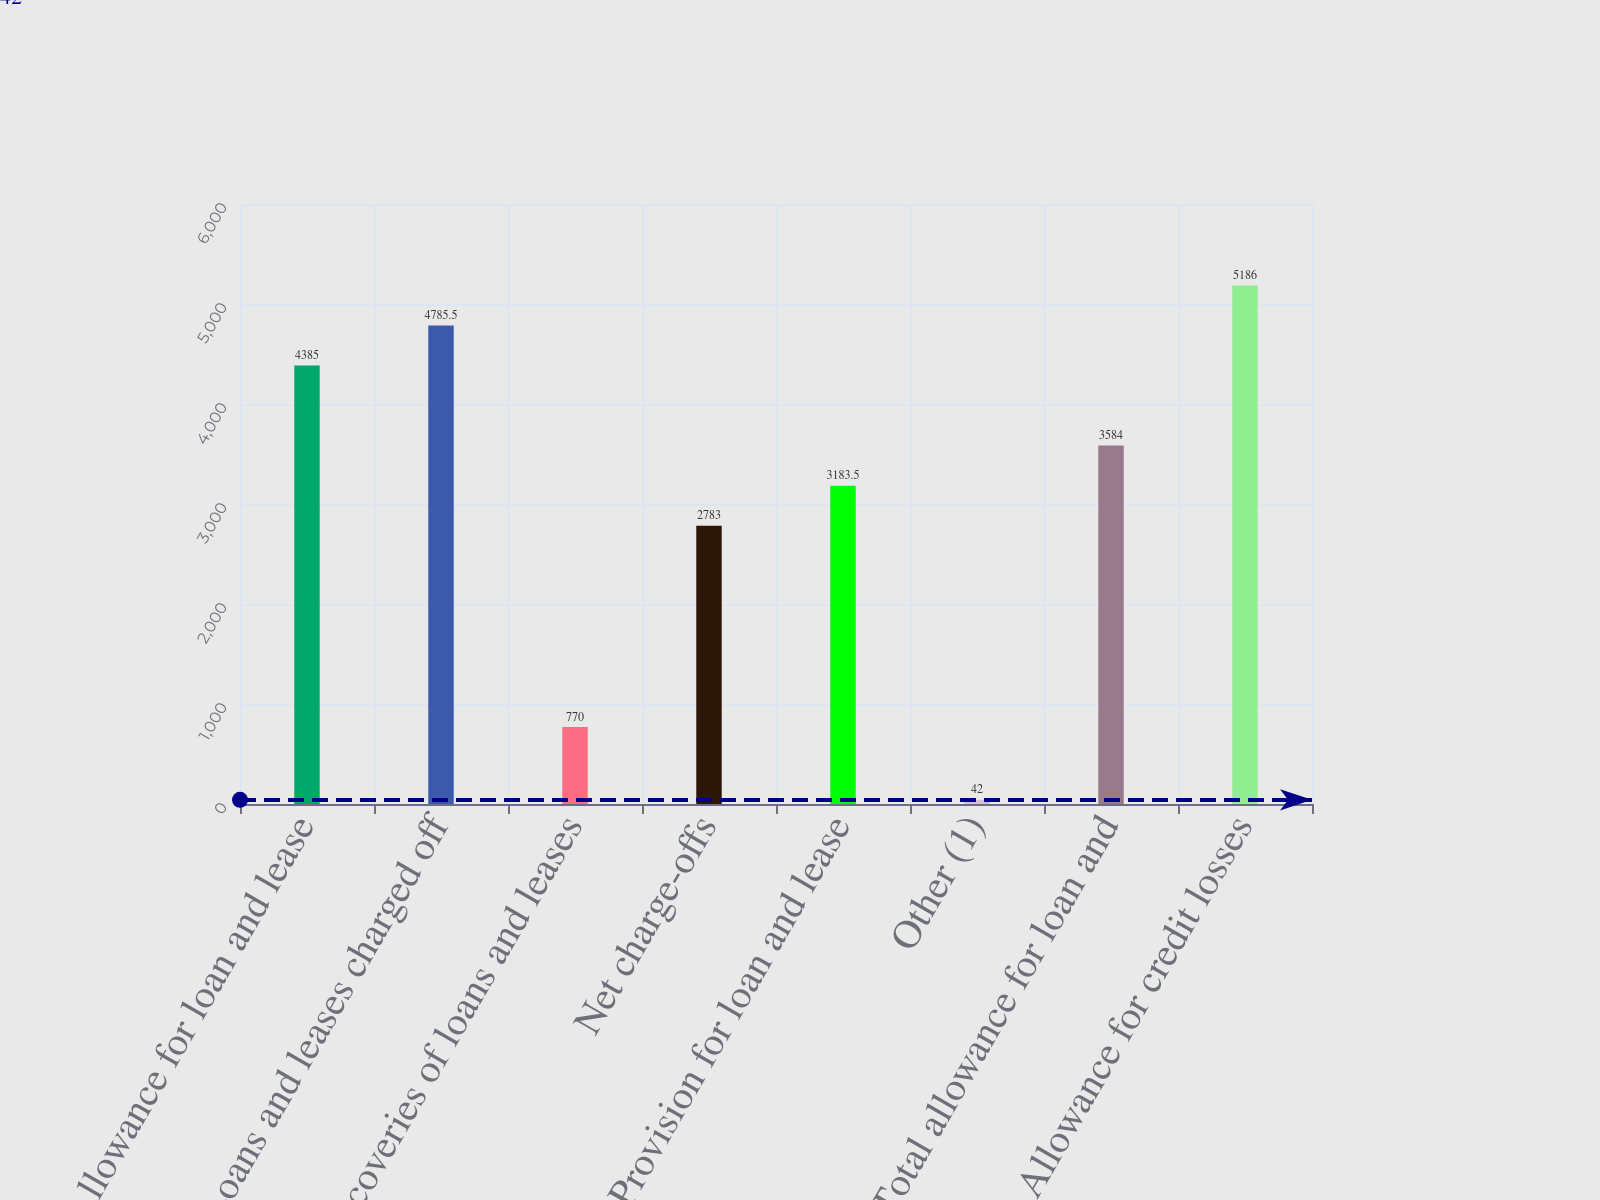Convert chart to OTSL. <chart><loc_0><loc_0><loc_500><loc_500><bar_chart><fcel>Allowance for loan and lease<fcel>Loans and leases charged off<fcel>Recoveries of loans and leases<fcel>Net charge-offs<fcel>Provision for loan and lease<fcel>Other (1)<fcel>Total allowance for loan and<fcel>Allowance for credit losses<nl><fcel>4385<fcel>4785.5<fcel>770<fcel>2783<fcel>3183.5<fcel>42<fcel>3584<fcel>5186<nl></chart> 